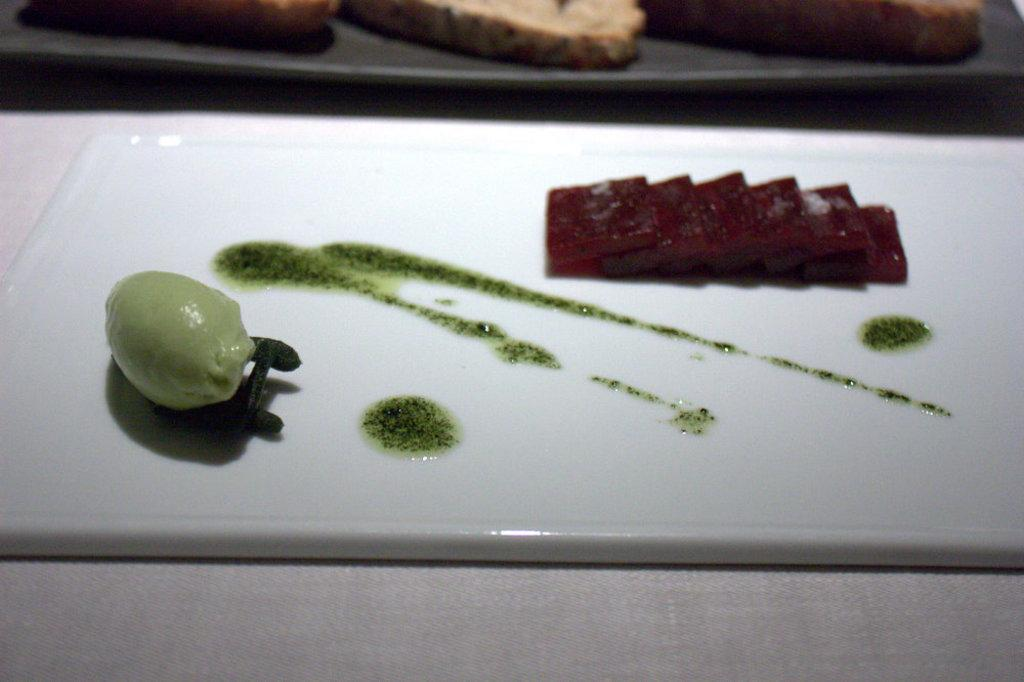What is on the chopping board in the image? There are food items on a chopping board in the image. Where is the chopping board located? The chopping board is on top of a table. What type of plants can be seen growing out of the head in the image? There is no head or plants present in the image; it only features a chopping board with food items on it and a table. 